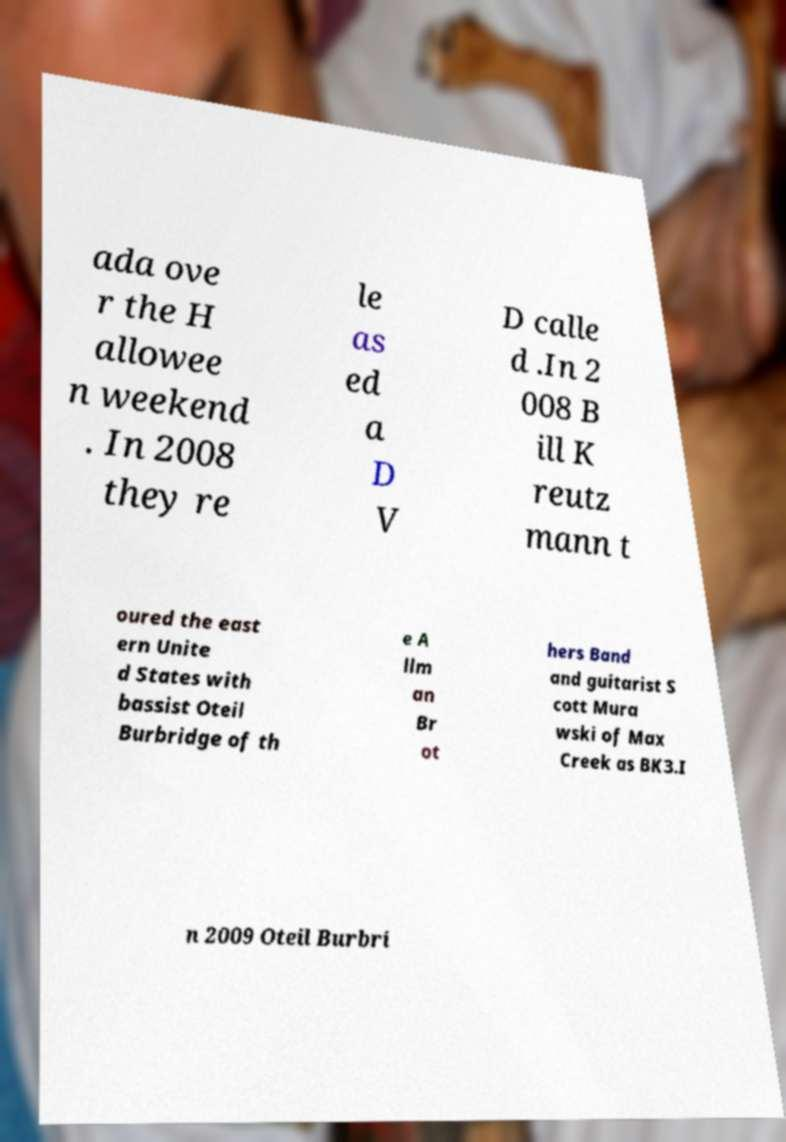Can you accurately transcribe the text from the provided image for me? ada ove r the H allowee n weekend . In 2008 they re le as ed a D V D calle d .In 2 008 B ill K reutz mann t oured the east ern Unite d States with bassist Oteil Burbridge of th e A llm an Br ot hers Band and guitarist S cott Mura wski of Max Creek as BK3.I n 2009 Oteil Burbri 